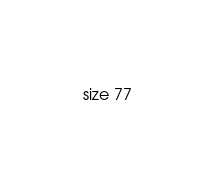<code> <loc_0><loc_0><loc_500><loc_500><_YAML_>size 77
</code> 